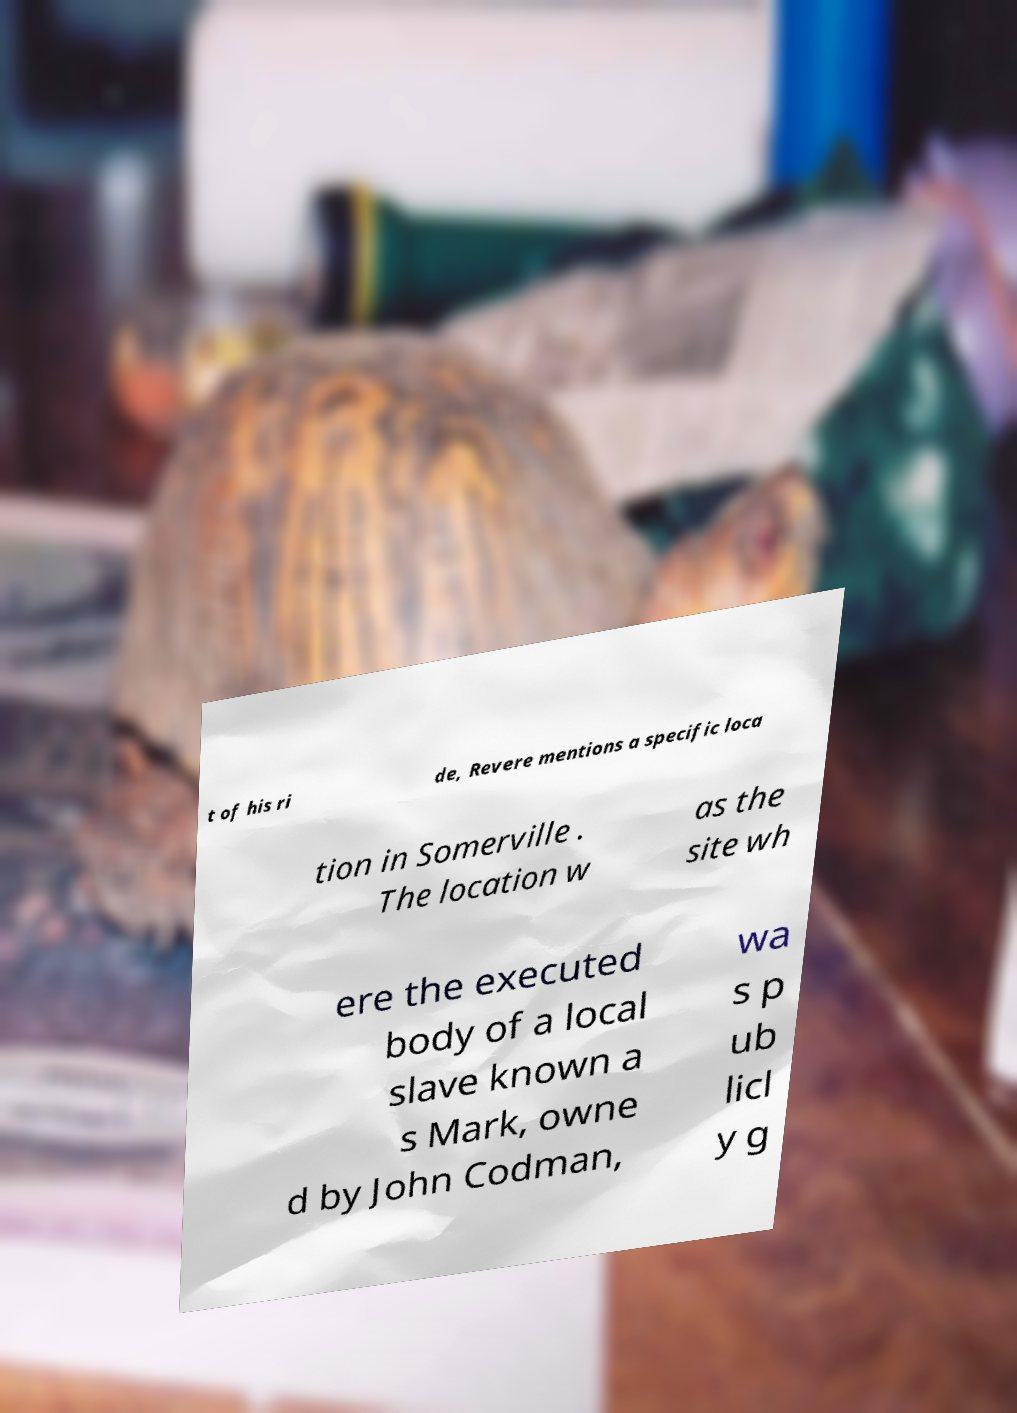Can you read and provide the text displayed in the image?This photo seems to have some interesting text. Can you extract and type it out for me? t of his ri de, Revere mentions a specific loca tion in Somerville . The location w as the site wh ere the executed body of a local slave known a s Mark, owne d by John Codman, wa s p ub licl y g 